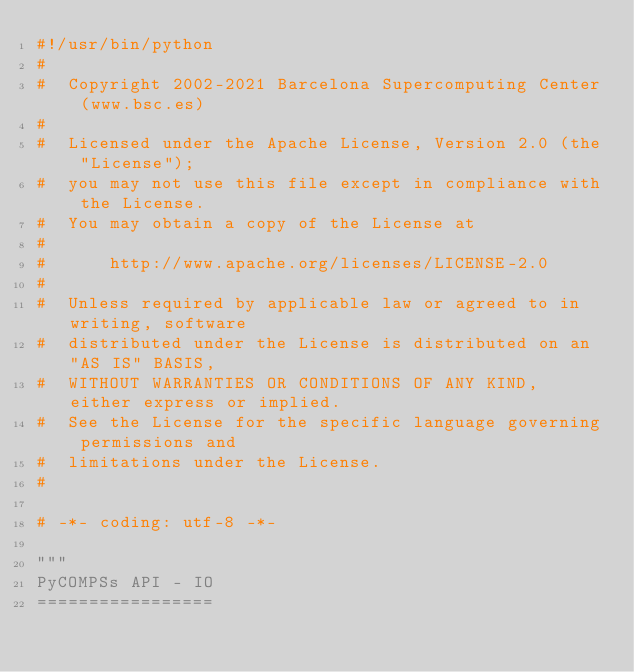Convert code to text. <code><loc_0><loc_0><loc_500><loc_500><_Python_>#!/usr/bin/python
#
#  Copyright 2002-2021 Barcelona Supercomputing Center (www.bsc.es)
#
#  Licensed under the Apache License, Version 2.0 (the "License");
#  you may not use this file except in compliance with the License.
#  You may obtain a copy of the License at
#
#      http://www.apache.org/licenses/LICENSE-2.0
#
#  Unless required by applicable law or agreed to in writing, software
#  distributed under the License is distributed on an "AS IS" BASIS,
#  WITHOUT WARRANTIES OR CONDITIONS OF ANY KIND, either express or implied.
#  See the License for the specific language governing permissions and
#  limitations under the License.
#

# -*- coding: utf-8 -*-

"""
PyCOMPSs API - IO
=================</code> 